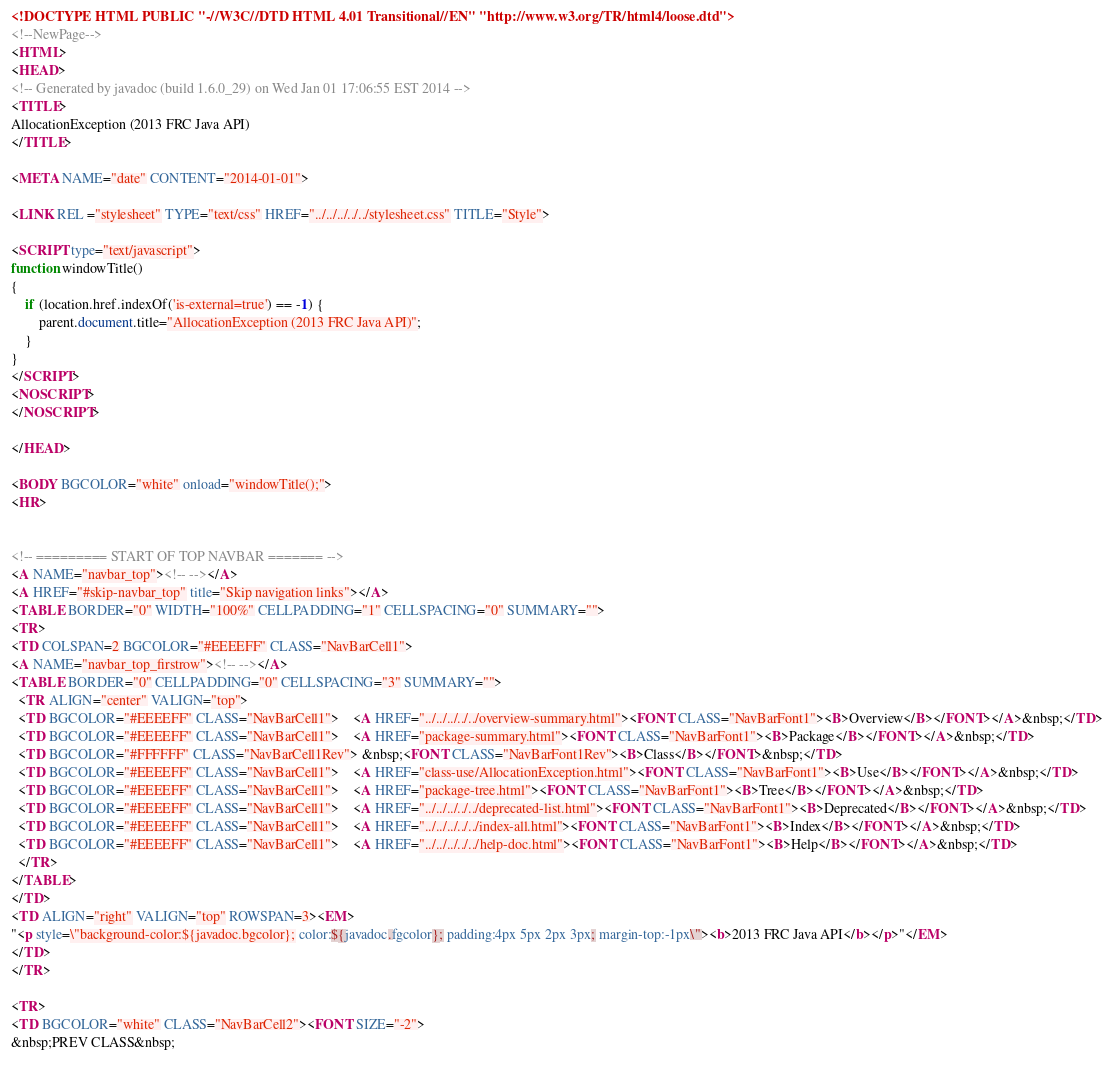<code> <loc_0><loc_0><loc_500><loc_500><_HTML_><!DOCTYPE HTML PUBLIC "-//W3C//DTD HTML 4.01 Transitional//EN" "http://www.w3.org/TR/html4/loose.dtd">
<!--NewPage-->
<HTML>
<HEAD>
<!-- Generated by javadoc (build 1.6.0_29) on Wed Jan 01 17:06:55 EST 2014 -->
<TITLE>
AllocationException (2013 FRC Java API)
</TITLE>

<META NAME="date" CONTENT="2014-01-01">

<LINK REL ="stylesheet" TYPE="text/css" HREF="../../../../../stylesheet.css" TITLE="Style">

<SCRIPT type="text/javascript">
function windowTitle()
{
    if (location.href.indexOf('is-external=true') == -1) {
        parent.document.title="AllocationException (2013 FRC Java API)";
    }
}
</SCRIPT>
<NOSCRIPT>
</NOSCRIPT>

</HEAD>

<BODY BGCOLOR="white" onload="windowTitle();">
<HR>


<!-- ========= START OF TOP NAVBAR ======= -->
<A NAME="navbar_top"><!-- --></A>
<A HREF="#skip-navbar_top" title="Skip navigation links"></A>
<TABLE BORDER="0" WIDTH="100%" CELLPADDING="1" CELLSPACING="0" SUMMARY="">
<TR>
<TD COLSPAN=2 BGCOLOR="#EEEEFF" CLASS="NavBarCell1">
<A NAME="navbar_top_firstrow"><!-- --></A>
<TABLE BORDER="0" CELLPADDING="0" CELLSPACING="3" SUMMARY="">
  <TR ALIGN="center" VALIGN="top">
  <TD BGCOLOR="#EEEEFF" CLASS="NavBarCell1">    <A HREF="../../../../../overview-summary.html"><FONT CLASS="NavBarFont1"><B>Overview</B></FONT></A>&nbsp;</TD>
  <TD BGCOLOR="#EEEEFF" CLASS="NavBarCell1">    <A HREF="package-summary.html"><FONT CLASS="NavBarFont1"><B>Package</B></FONT></A>&nbsp;</TD>
  <TD BGCOLOR="#FFFFFF" CLASS="NavBarCell1Rev"> &nbsp;<FONT CLASS="NavBarFont1Rev"><B>Class</B></FONT>&nbsp;</TD>
  <TD BGCOLOR="#EEEEFF" CLASS="NavBarCell1">    <A HREF="class-use/AllocationException.html"><FONT CLASS="NavBarFont1"><B>Use</B></FONT></A>&nbsp;</TD>
  <TD BGCOLOR="#EEEEFF" CLASS="NavBarCell1">    <A HREF="package-tree.html"><FONT CLASS="NavBarFont1"><B>Tree</B></FONT></A>&nbsp;</TD>
  <TD BGCOLOR="#EEEEFF" CLASS="NavBarCell1">    <A HREF="../../../../../deprecated-list.html"><FONT CLASS="NavBarFont1"><B>Deprecated</B></FONT></A>&nbsp;</TD>
  <TD BGCOLOR="#EEEEFF" CLASS="NavBarCell1">    <A HREF="../../../../../index-all.html"><FONT CLASS="NavBarFont1"><B>Index</B></FONT></A>&nbsp;</TD>
  <TD BGCOLOR="#EEEEFF" CLASS="NavBarCell1">    <A HREF="../../../../../help-doc.html"><FONT CLASS="NavBarFont1"><B>Help</B></FONT></A>&nbsp;</TD>
  </TR>
</TABLE>
</TD>
<TD ALIGN="right" VALIGN="top" ROWSPAN=3><EM>
"<p style=\"background-color:${javadoc.bgcolor}; color:${javadoc.fgcolor}; padding:4px 5px 2px 3px; margin-top:-1px\"><b>2013 FRC Java API</b></p>"</EM>
</TD>
</TR>

<TR>
<TD BGCOLOR="white" CLASS="NavBarCell2"><FONT SIZE="-2">
&nbsp;PREV CLASS&nbsp;</code> 